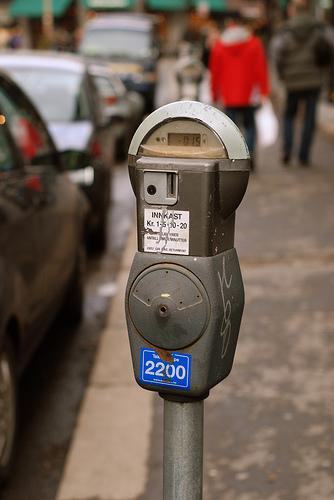What is the primary color of the sticker with numbers on the parking meter? The sticker with numbers on the parking meter is primarily blue. What type of bag is a person carrying and what is its color? A person is carrying a white shopping bag. Provide a short description of the content displayed on the parking meter's digital screen. The digital screen on the parking meter displays a number and a minus sign. Count the number of people in the image and describe what they are wearing. There are 2 people in the image: one person wearing a red jacket and the other person wearing an orange jacket. What is the number displayed on the blue sticker? The number displayed on the blue sticker is 2200. Identify the purple umbrella held by the person in red. The umbrella has crooked spokes. There is a person in a red jacket, but there is no mention of an umbrella in any of the given captions or objects. This instruction is misleading as it requests the user to find an item that doesn't exist in the image. Can you spot the colorful graffiti on the brick wall behind the person in orange? The graffiti contains a message in black lettering. There is a person with an orange jacket and a brick wall, but there is no mention of graffiti or any related objects in the given captions or objects. This instruction is misleading as it directs the user to find an item that doesn't exist in the image. Notice the small dog sitting next to the parking meter. It has a blue collar with a golden tag. There is a parking meter in the image, but there is no mention of a dog or any related objects in the given captions or objects. This instruction is misleading because it instructs the user to find a non-existent item in the image. Could you find the bicycle leaning against the wall? Its tires are deflated. There is no bicycle mentioned in any of the given captions or objects. This instruction is misleading as it asks the user to find a non-existent object in the image. Observe the yellow taxi cab driving past the parked cars. The taxi's license plate reads "XYZ 123." There are parked cars, but there is no mention of a taxi cab or a related object in the given captions or objects. This instruction is misleading as it instructs the user to locate a non-existent object in the image. Find the green traffic light hanging above the road. The light is currently turned red. There is a road in the image, but there is no mention of a traffic light or any related objects in the given captions or objects. This instruction is misleading as it asks the user to find an object that is not present in the image. 